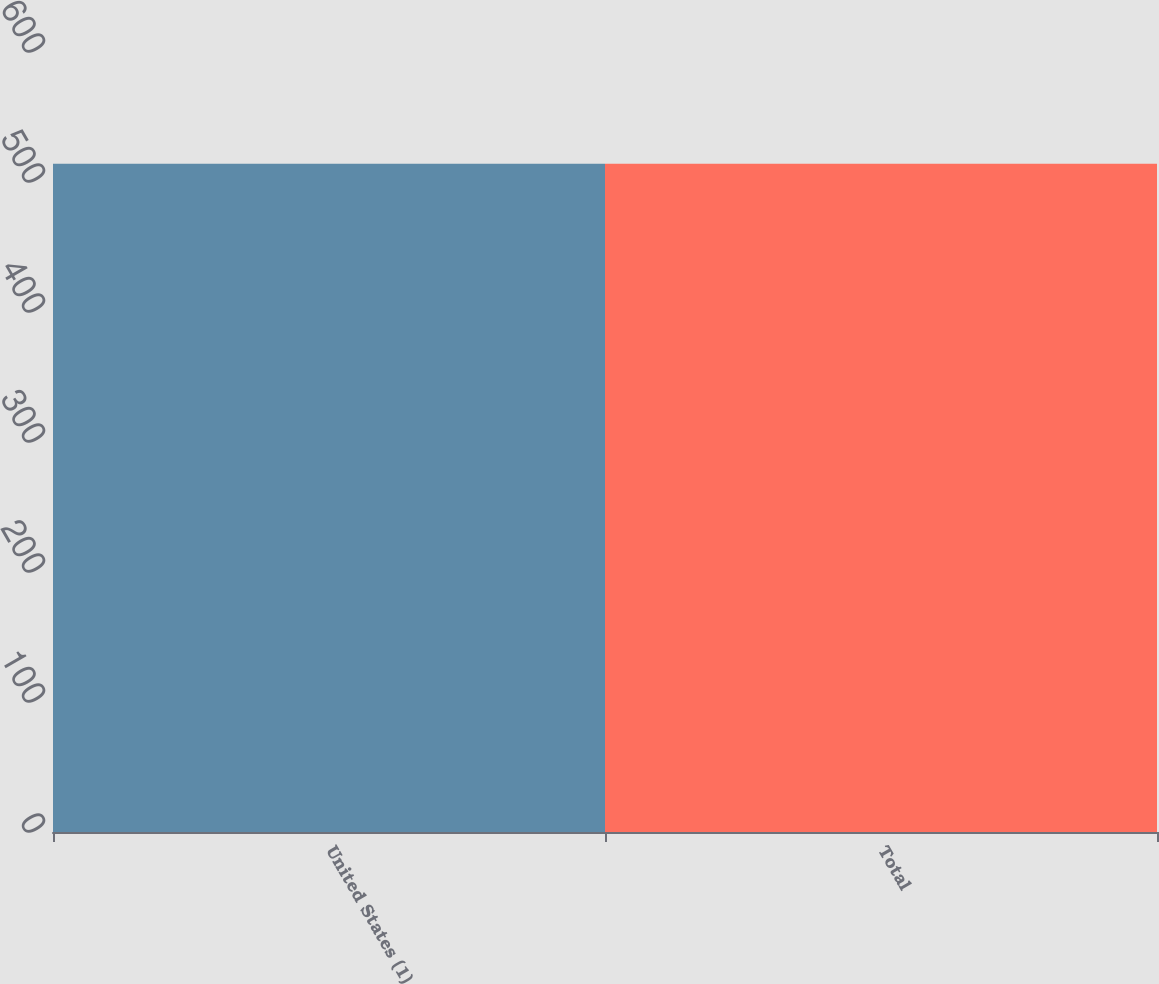<chart> <loc_0><loc_0><loc_500><loc_500><bar_chart><fcel>United States (1)<fcel>Total<nl><fcel>514<fcel>514.1<nl></chart> 